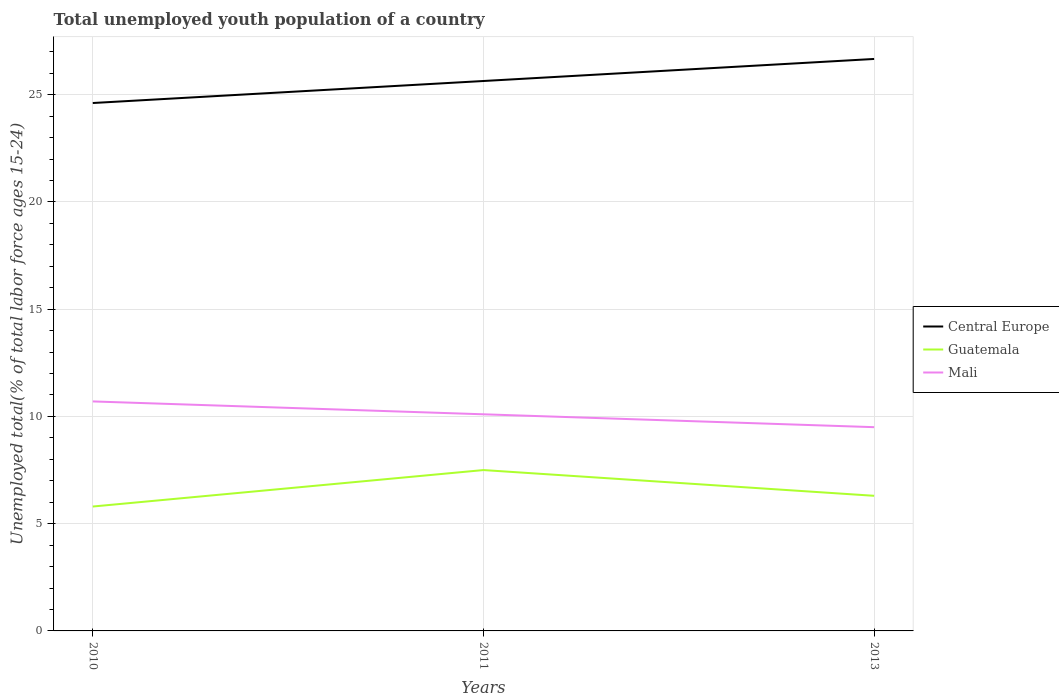How many different coloured lines are there?
Your answer should be very brief. 3. Across all years, what is the maximum percentage of total unemployed youth population of a country in Guatemala?
Your answer should be compact. 5.8. What is the total percentage of total unemployed youth population of a country in Mali in the graph?
Your answer should be compact. 0.6. What is the difference between the highest and the second highest percentage of total unemployed youth population of a country in Mali?
Give a very brief answer. 1.2. How many lines are there?
Offer a very short reply. 3. Does the graph contain any zero values?
Your answer should be very brief. No. Does the graph contain grids?
Your answer should be very brief. Yes. What is the title of the graph?
Provide a short and direct response. Total unemployed youth population of a country. What is the label or title of the X-axis?
Your response must be concise. Years. What is the label or title of the Y-axis?
Your answer should be very brief. Unemployed total(% of total labor force ages 15-24). What is the Unemployed total(% of total labor force ages 15-24) in Central Europe in 2010?
Offer a very short reply. 24.61. What is the Unemployed total(% of total labor force ages 15-24) of Guatemala in 2010?
Keep it short and to the point. 5.8. What is the Unemployed total(% of total labor force ages 15-24) in Mali in 2010?
Ensure brevity in your answer.  10.7. What is the Unemployed total(% of total labor force ages 15-24) in Central Europe in 2011?
Offer a very short reply. 25.64. What is the Unemployed total(% of total labor force ages 15-24) in Mali in 2011?
Your response must be concise. 10.1. What is the Unemployed total(% of total labor force ages 15-24) of Central Europe in 2013?
Offer a very short reply. 26.67. What is the Unemployed total(% of total labor force ages 15-24) in Guatemala in 2013?
Ensure brevity in your answer.  6.3. Across all years, what is the maximum Unemployed total(% of total labor force ages 15-24) of Central Europe?
Offer a very short reply. 26.67. Across all years, what is the maximum Unemployed total(% of total labor force ages 15-24) of Guatemala?
Offer a very short reply. 7.5. Across all years, what is the maximum Unemployed total(% of total labor force ages 15-24) of Mali?
Offer a very short reply. 10.7. Across all years, what is the minimum Unemployed total(% of total labor force ages 15-24) of Central Europe?
Provide a short and direct response. 24.61. Across all years, what is the minimum Unemployed total(% of total labor force ages 15-24) in Guatemala?
Your response must be concise. 5.8. Across all years, what is the minimum Unemployed total(% of total labor force ages 15-24) of Mali?
Provide a short and direct response. 9.5. What is the total Unemployed total(% of total labor force ages 15-24) of Central Europe in the graph?
Your answer should be very brief. 76.92. What is the total Unemployed total(% of total labor force ages 15-24) of Guatemala in the graph?
Offer a very short reply. 19.6. What is the total Unemployed total(% of total labor force ages 15-24) of Mali in the graph?
Your answer should be very brief. 30.3. What is the difference between the Unemployed total(% of total labor force ages 15-24) of Central Europe in 2010 and that in 2011?
Your answer should be very brief. -1.03. What is the difference between the Unemployed total(% of total labor force ages 15-24) of Guatemala in 2010 and that in 2011?
Provide a succinct answer. -1.7. What is the difference between the Unemployed total(% of total labor force ages 15-24) of Mali in 2010 and that in 2011?
Your response must be concise. 0.6. What is the difference between the Unemployed total(% of total labor force ages 15-24) in Central Europe in 2010 and that in 2013?
Make the answer very short. -2.05. What is the difference between the Unemployed total(% of total labor force ages 15-24) in Guatemala in 2010 and that in 2013?
Keep it short and to the point. -0.5. What is the difference between the Unemployed total(% of total labor force ages 15-24) of Mali in 2010 and that in 2013?
Make the answer very short. 1.2. What is the difference between the Unemployed total(% of total labor force ages 15-24) of Central Europe in 2011 and that in 2013?
Ensure brevity in your answer.  -1.03. What is the difference between the Unemployed total(% of total labor force ages 15-24) in Guatemala in 2011 and that in 2013?
Your answer should be very brief. 1.2. What is the difference between the Unemployed total(% of total labor force ages 15-24) of Mali in 2011 and that in 2013?
Provide a succinct answer. 0.6. What is the difference between the Unemployed total(% of total labor force ages 15-24) in Central Europe in 2010 and the Unemployed total(% of total labor force ages 15-24) in Guatemala in 2011?
Keep it short and to the point. 17.11. What is the difference between the Unemployed total(% of total labor force ages 15-24) in Central Europe in 2010 and the Unemployed total(% of total labor force ages 15-24) in Mali in 2011?
Provide a short and direct response. 14.51. What is the difference between the Unemployed total(% of total labor force ages 15-24) of Guatemala in 2010 and the Unemployed total(% of total labor force ages 15-24) of Mali in 2011?
Provide a succinct answer. -4.3. What is the difference between the Unemployed total(% of total labor force ages 15-24) of Central Europe in 2010 and the Unemployed total(% of total labor force ages 15-24) of Guatemala in 2013?
Ensure brevity in your answer.  18.31. What is the difference between the Unemployed total(% of total labor force ages 15-24) of Central Europe in 2010 and the Unemployed total(% of total labor force ages 15-24) of Mali in 2013?
Provide a short and direct response. 15.11. What is the difference between the Unemployed total(% of total labor force ages 15-24) of Guatemala in 2010 and the Unemployed total(% of total labor force ages 15-24) of Mali in 2013?
Provide a short and direct response. -3.7. What is the difference between the Unemployed total(% of total labor force ages 15-24) in Central Europe in 2011 and the Unemployed total(% of total labor force ages 15-24) in Guatemala in 2013?
Offer a very short reply. 19.34. What is the difference between the Unemployed total(% of total labor force ages 15-24) of Central Europe in 2011 and the Unemployed total(% of total labor force ages 15-24) of Mali in 2013?
Give a very brief answer. 16.14. What is the difference between the Unemployed total(% of total labor force ages 15-24) in Guatemala in 2011 and the Unemployed total(% of total labor force ages 15-24) in Mali in 2013?
Offer a very short reply. -2. What is the average Unemployed total(% of total labor force ages 15-24) in Central Europe per year?
Offer a very short reply. 25.64. What is the average Unemployed total(% of total labor force ages 15-24) of Guatemala per year?
Keep it short and to the point. 6.53. In the year 2010, what is the difference between the Unemployed total(% of total labor force ages 15-24) of Central Europe and Unemployed total(% of total labor force ages 15-24) of Guatemala?
Your answer should be very brief. 18.81. In the year 2010, what is the difference between the Unemployed total(% of total labor force ages 15-24) of Central Europe and Unemployed total(% of total labor force ages 15-24) of Mali?
Provide a succinct answer. 13.91. In the year 2010, what is the difference between the Unemployed total(% of total labor force ages 15-24) of Guatemala and Unemployed total(% of total labor force ages 15-24) of Mali?
Make the answer very short. -4.9. In the year 2011, what is the difference between the Unemployed total(% of total labor force ages 15-24) in Central Europe and Unemployed total(% of total labor force ages 15-24) in Guatemala?
Your response must be concise. 18.14. In the year 2011, what is the difference between the Unemployed total(% of total labor force ages 15-24) in Central Europe and Unemployed total(% of total labor force ages 15-24) in Mali?
Offer a terse response. 15.54. In the year 2011, what is the difference between the Unemployed total(% of total labor force ages 15-24) of Guatemala and Unemployed total(% of total labor force ages 15-24) of Mali?
Your answer should be very brief. -2.6. In the year 2013, what is the difference between the Unemployed total(% of total labor force ages 15-24) in Central Europe and Unemployed total(% of total labor force ages 15-24) in Guatemala?
Offer a terse response. 20.37. In the year 2013, what is the difference between the Unemployed total(% of total labor force ages 15-24) in Central Europe and Unemployed total(% of total labor force ages 15-24) in Mali?
Ensure brevity in your answer.  17.17. In the year 2013, what is the difference between the Unemployed total(% of total labor force ages 15-24) in Guatemala and Unemployed total(% of total labor force ages 15-24) in Mali?
Provide a succinct answer. -3.2. What is the ratio of the Unemployed total(% of total labor force ages 15-24) in Central Europe in 2010 to that in 2011?
Your response must be concise. 0.96. What is the ratio of the Unemployed total(% of total labor force ages 15-24) of Guatemala in 2010 to that in 2011?
Provide a succinct answer. 0.77. What is the ratio of the Unemployed total(% of total labor force ages 15-24) in Mali in 2010 to that in 2011?
Keep it short and to the point. 1.06. What is the ratio of the Unemployed total(% of total labor force ages 15-24) in Central Europe in 2010 to that in 2013?
Keep it short and to the point. 0.92. What is the ratio of the Unemployed total(% of total labor force ages 15-24) in Guatemala in 2010 to that in 2013?
Give a very brief answer. 0.92. What is the ratio of the Unemployed total(% of total labor force ages 15-24) in Mali in 2010 to that in 2013?
Make the answer very short. 1.13. What is the ratio of the Unemployed total(% of total labor force ages 15-24) in Central Europe in 2011 to that in 2013?
Ensure brevity in your answer.  0.96. What is the ratio of the Unemployed total(% of total labor force ages 15-24) in Guatemala in 2011 to that in 2013?
Ensure brevity in your answer.  1.19. What is the ratio of the Unemployed total(% of total labor force ages 15-24) of Mali in 2011 to that in 2013?
Offer a terse response. 1.06. What is the difference between the highest and the second highest Unemployed total(% of total labor force ages 15-24) of Central Europe?
Provide a succinct answer. 1.03. What is the difference between the highest and the second highest Unemployed total(% of total labor force ages 15-24) in Mali?
Provide a short and direct response. 0.6. What is the difference between the highest and the lowest Unemployed total(% of total labor force ages 15-24) of Central Europe?
Provide a succinct answer. 2.05. What is the difference between the highest and the lowest Unemployed total(% of total labor force ages 15-24) in Guatemala?
Offer a terse response. 1.7. What is the difference between the highest and the lowest Unemployed total(% of total labor force ages 15-24) of Mali?
Offer a terse response. 1.2. 